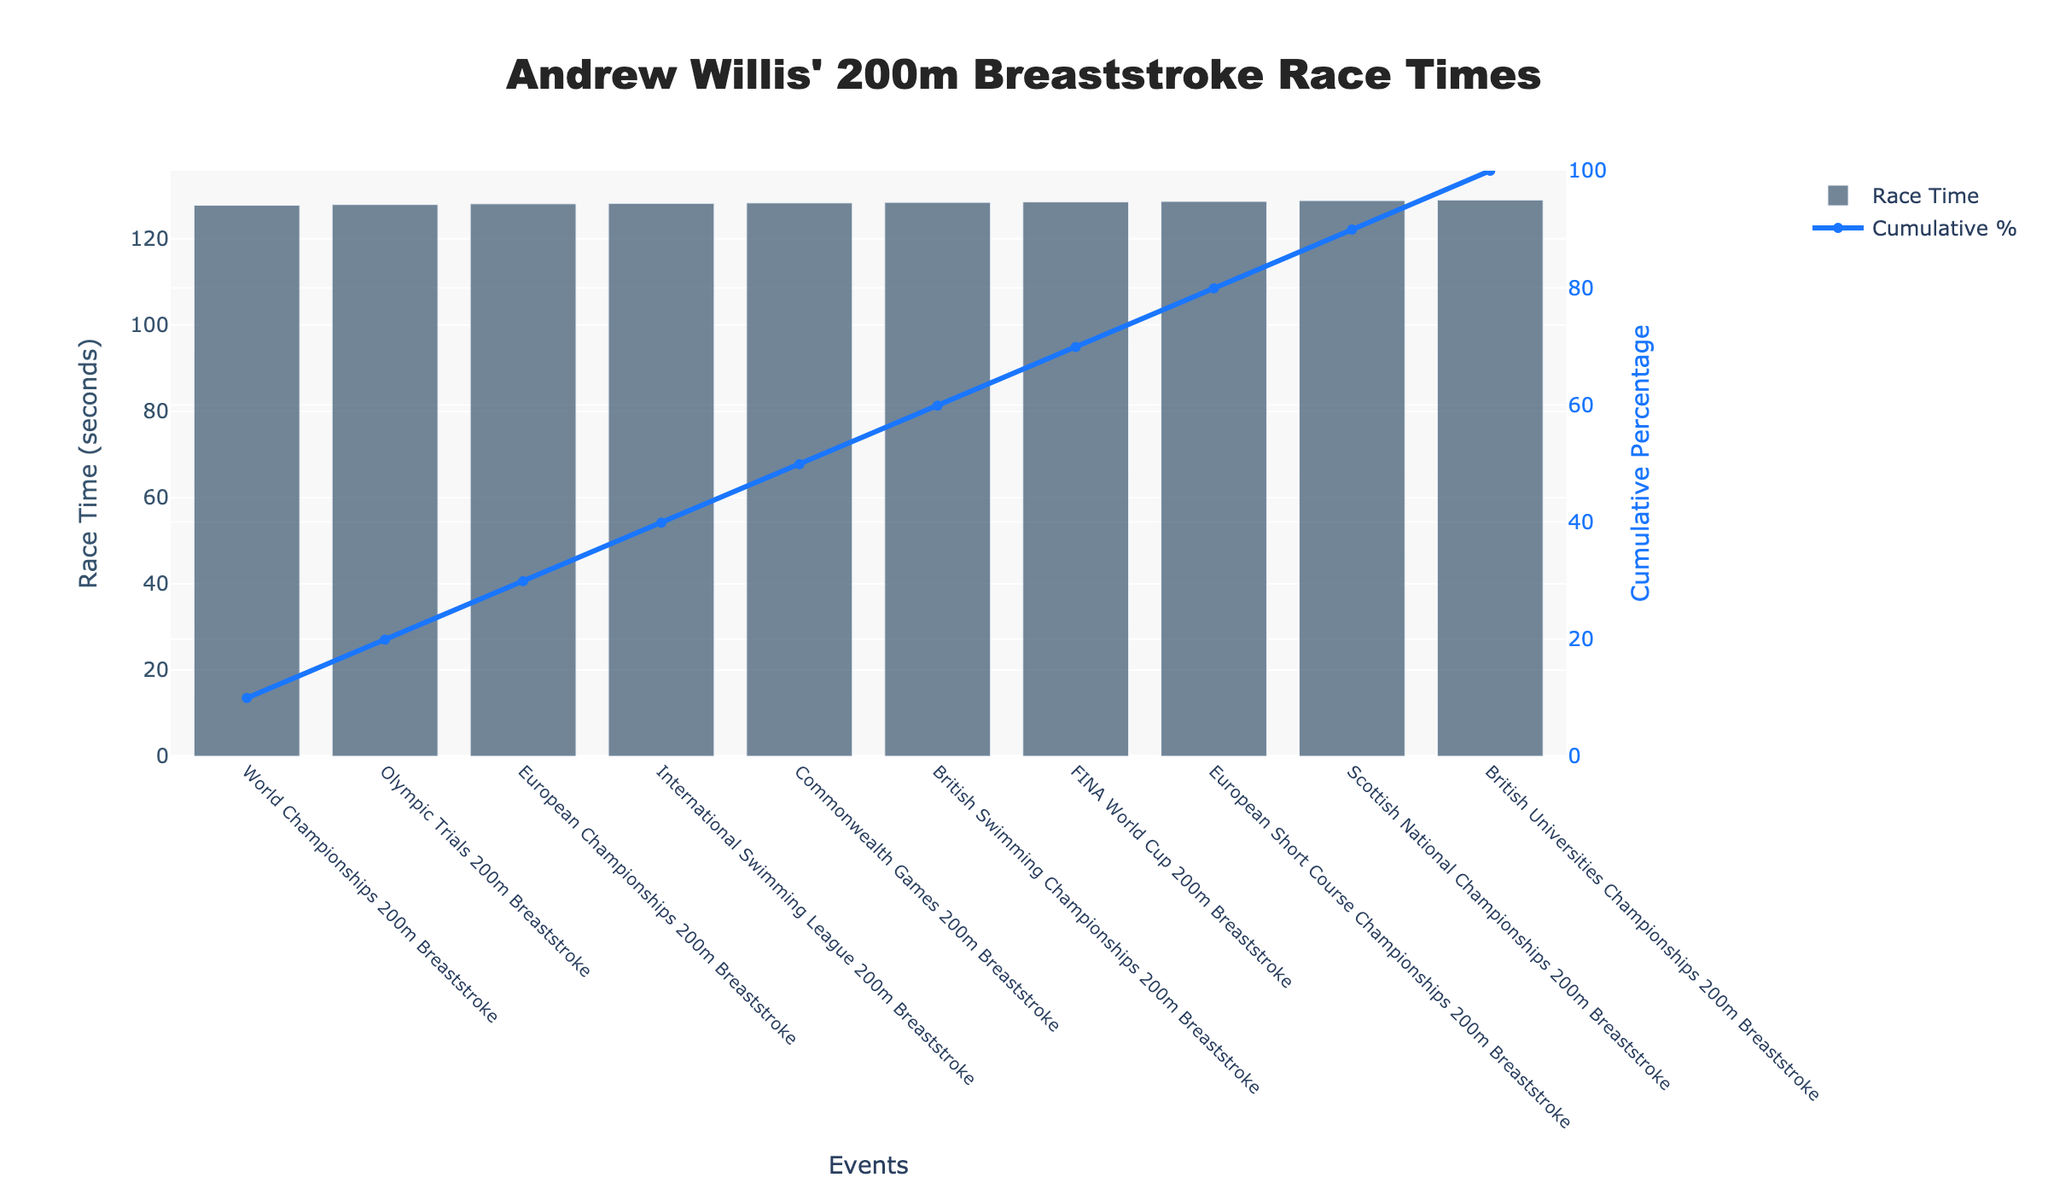What's the title of the chart? The title of the chart is clearly displayed at the top of the figure.
Answer: Andrew Willis' 200m Breaststroke Race Times Which event had the fastest race time for Andrew Willis? Look for the shortest bar in the bar chart, which corresponds to the fastest race time. The shortest bar is labeled "World Championships 200m Breaststroke".
Answer: World Championships 200m Breaststroke Which event had the slowest race time for Andrew Willis? Identify the tallest bar in the bar chart, representing the slowest race time. The tallest bar is labeled "British Universities Championships 200m Breaststroke".
Answer: British Universities Championships 200m Breaststroke How many events are displayed in the chart? Count the number of bars in the bar chart, as each bar represents a separate event.
Answer: 10 What cumulative percentage is reached after the first three events with the fastest times? Find the first three bars (which correspond to the fastest times due to sorting) and refer to the line chart that shows cumulative percentage. After "World Championships 200m Breaststroke", "European Championships 200m Breaststroke", and "Olympic Trials 200m Breaststroke", look at the value on the cumulative percentage line above the third event.
Answer: Around 38% What is the cumulative percentage for the event "International Swimming League 200m Breaststroke"? Locate the "International Swimming League 200m Breaststroke" bar on the x-axis and then look above it to find the value on the cumulative percentage line.
Answer: Approx. 60% How does the race time of the "Commonwealth Games 200m Breaststroke" compare to the "European Championships 200m Breaststroke"? Compare the heights of the bars labeled "Commonwealth Games 200m Breaststroke" and "European Championships 200m Breaststroke". "European Championships 200m Breaststroke" has a lower (shorter) bar indicating a faster time.
Answer: Commonwealth Games is slower What percentage of the total race time is accumulated by the “Olympic Trials 200m Breaststroke”? The “Olympic Trials 200m Breaststroke” is the fifth event. The cumulative percentage line at this position represents the accumulated percentage.
Answer: Around 56% Which event marks the start of the final 20% of cumulative race times? Find the point on the line chart where it starts from around 80% and goes to 100%. The event just before this rise marks the start of the final 20%.
Answer: International Swimming League 200m Breaststroke 